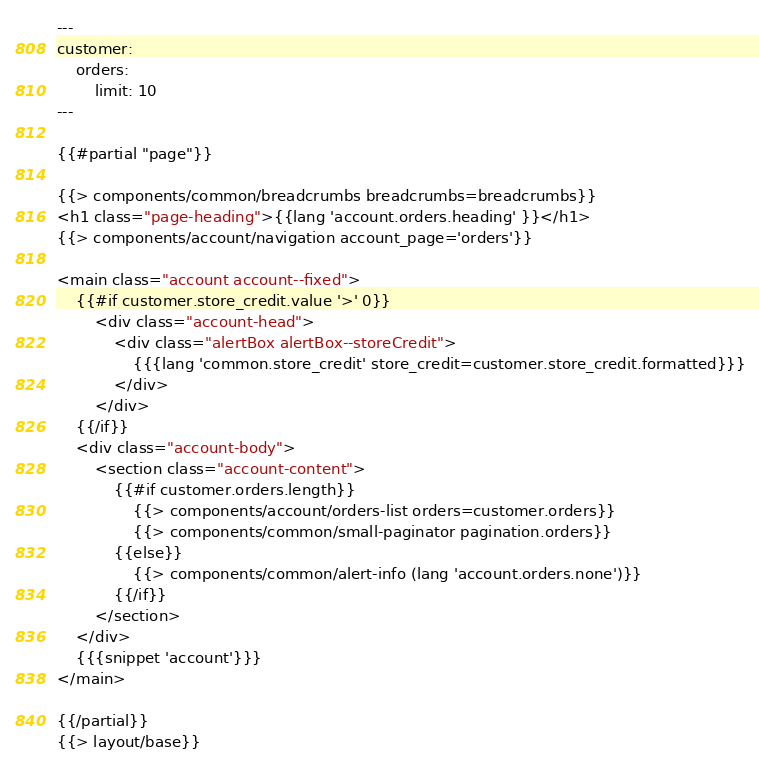Convert code to text. <code><loc_0><loc_0><loc_500><loc_500><_HTML_>---
customer:
    orders:
        limit: 10
---

{{#partial "page"}}

{{> components/common/breadcrumbs breadcrumbs=breadcrumbs}}
<h1 class="page-heading">{{lang 'account.orders.heading' }}</h1>
{{> components/account/navigation account_page='orders'}}

<main class="account account--fixed">
    {{#if customer.store_credit.value '>' 0}}
        <div class="account-head">
            <div class="alertBox alertBox--storeCredit">
                {{{lang 'common.store_credit' store_credit=customer.store_credit.formatted}}}
            </div>
        </div>
    {{/if}}
    <div class="account-body">
        <section class="account-content">
            {{#if customer.orders.length}}
                {{> components/account/orders-list orders=customer.orders}}
                {{> components/common/small-paginator pagination.orders}}
            {{else}}
                {{> components/common/alert-info (lang 'account.orders.none')}}
            {{/if}}
        </section>
    </div>
    {{{snippet 'account'}}}
</main>

{{/partial}}
{{> layout/base}}
</code> 